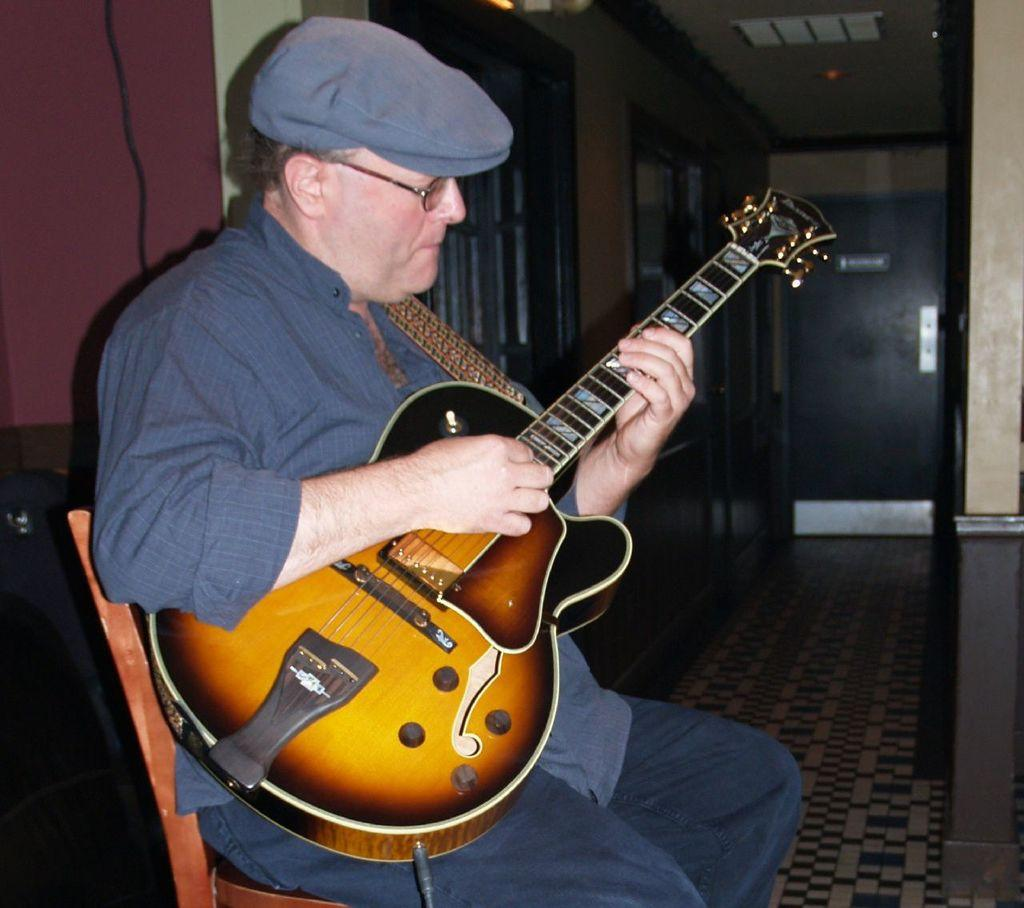What is the main subject of the image? The main subject of the image is a man. Can you describe the man's attire? The man is wearing a cap and spectacles. What is the man doing in the image? The man is sitting on a chair and playing the guitar. What can be seen in the background of the image? There is a wall in the background of the image. What type of cast can be seen on the man's leg in the image? There is no cast visible on the man's leg in the image. Can you tell me how many swings are present in the playground behind the man? There is no playground present in the image; it only features a wall in the background. 